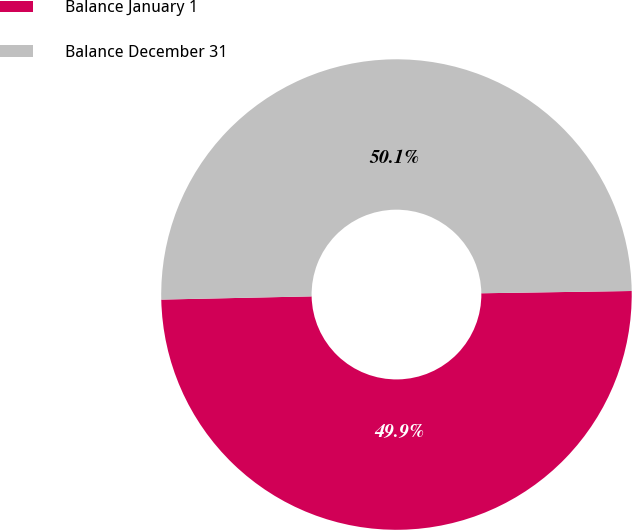Convert chart to OTSL. <chart><loc_0><loc_0><loc_500><loc_500><pie_chart><fcel>Balance January 1<fcel>Balance December 31<nl><fcel>49.9%<fcel>50.1%<nl></chart> 